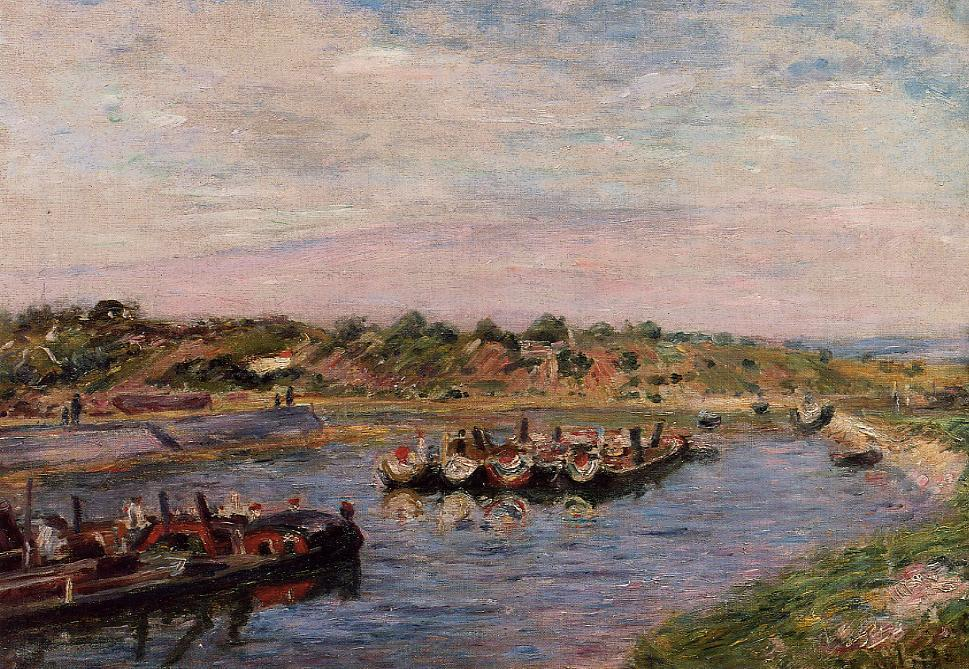Can you provide more details about the significance of the boats in this painting? Certainly! The array of boats prominently featured in the river illustrates a bustling waterway, crucial for local transport or trade. The presence of flags and the detailed decoration on some boats suggest that this may also be a special occasion, possibly a boat parade or a local boating event, which were popular in impressionist settings to socialize and celebrate community life. 